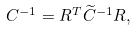Convert formula to latex. <formula><loc_0><loc_0><loc_500><loc_500>C ^ { - 1 } = R ^ { T } \widetilde { C } ^ { - 1 } R ,</formula> 